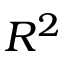<formula> <loc_0><loc_0><loc_500><loc_500>R ^ { 2 }</formula> 